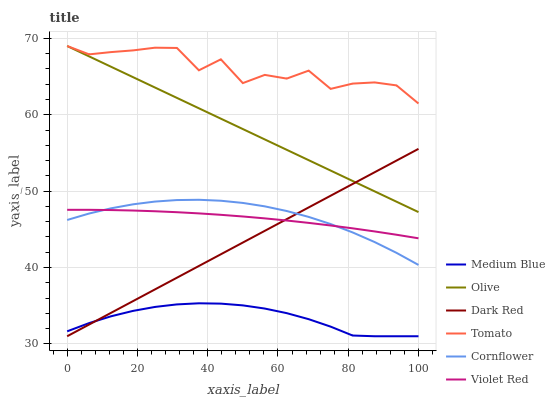Does Medium Blue have the minimum area under the curve?
Answer yes or no. Yes. Does Tomato have the maximum area under the curve?
Answer yes or no. Yes. Does Cornflower have the minimum area under the curve?
Answer yes or no. No. Does Cornflower have the maximum area under the curve?
Answer yes or no. No. Is Dark Red the smoothest?
Answer yes or no. Yes. Is Tomato the roughest?
Answer yes or no. Yes. Is Cornflower the smoothest?
Answer yes or no. No. Is Cornflower the roughest?
Answer yes or no. No. Does Dark Red have the lowest value?
Answer yes or no. Yes. Does Cornflower have the lowest value?
Answer yes or no. No. Does Olive have the highest value?
Answer yes or no. Yes. Does Cornflower have the highest value?
Answer yes or no. No. Is Violet Red less than Tomato?
Answer yes or no. Yes. Is Tomato greater than Dark Red?
Answer yes or no. Yes. Does Medium Blue intersect Dark Red?
Answer yes or no. Yes. Is Medium Blue less than Dark Red?
Answer yes or no. No. Is Medium Blue greater than Dark Red?
Answer yes or no. No. Does Violet Red intersect Tomato?
Answer yes or no. No. 